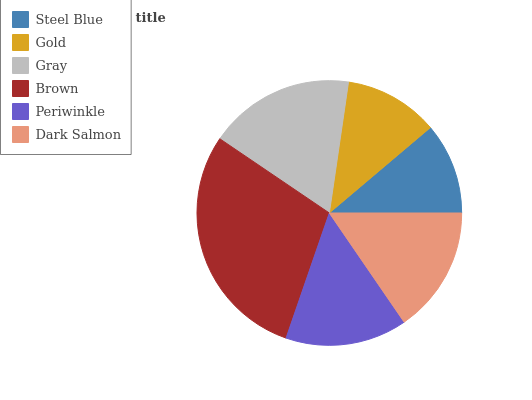Is Steel Blue the minimum?
Answer yes or no. Yes. Is Brown the maximum?
Answer yes or no. Yes. Is Gold the minimum?
Answer yes or no. No. Is Gold the maximum?
Answer yes or no. No. Is Gold greater than Steel Blue?
Answer yes or no. Yes. Is Steel Blue less than Gold?
Answer yes or no. Yes. Is Steel Blue greater than Gold?
Answer yes or no. No. Is Gold less than Steel Blue?
Answer yes or no. No. Is Dark Salmon the high median?
Answer yes or no. Yes. Is Periwinkle the low median?
Answer yes or no. Yes. Is Gold the high median?
Answer yes or no. No. Is Brown the low median?
Answer yes or no. No. 